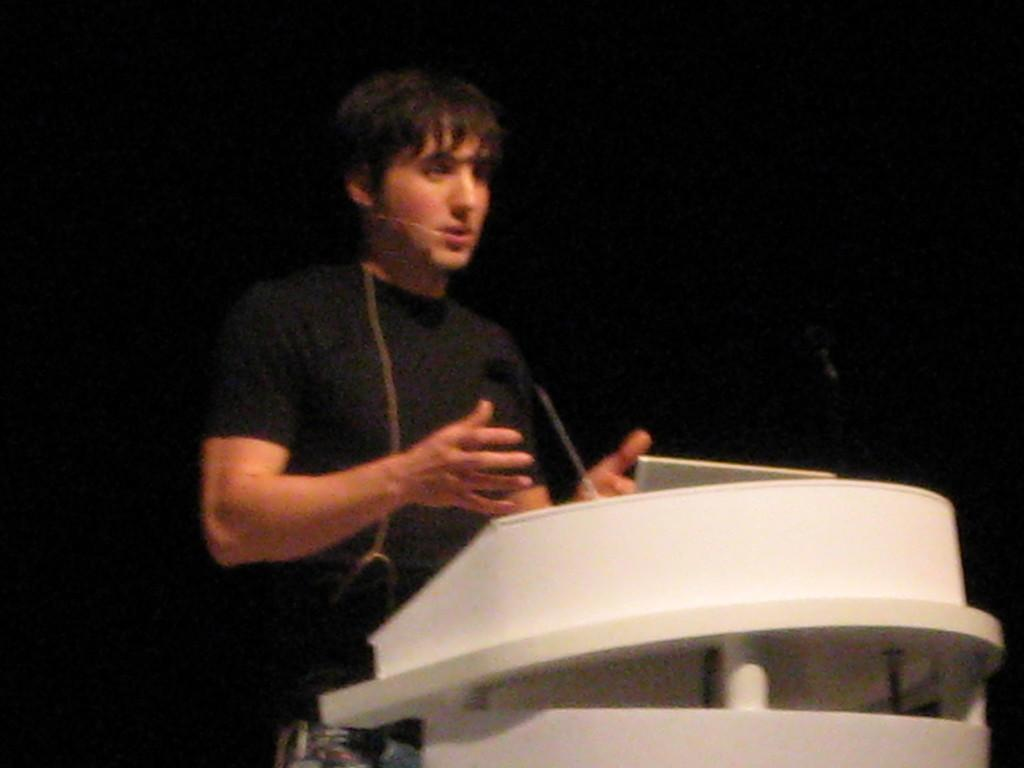What is the person in the image doing? The person is standing in front of the podium. What is on the podium? There is a microphone and a black object on the podium. What is the color of the background in the image? The background of the image is black in color. How does the size of the rainstorm affect the value of the black object on the podium? There is no rainstorm present in the image, and therefore its size and effect on the value of the black object cannot be determined. 